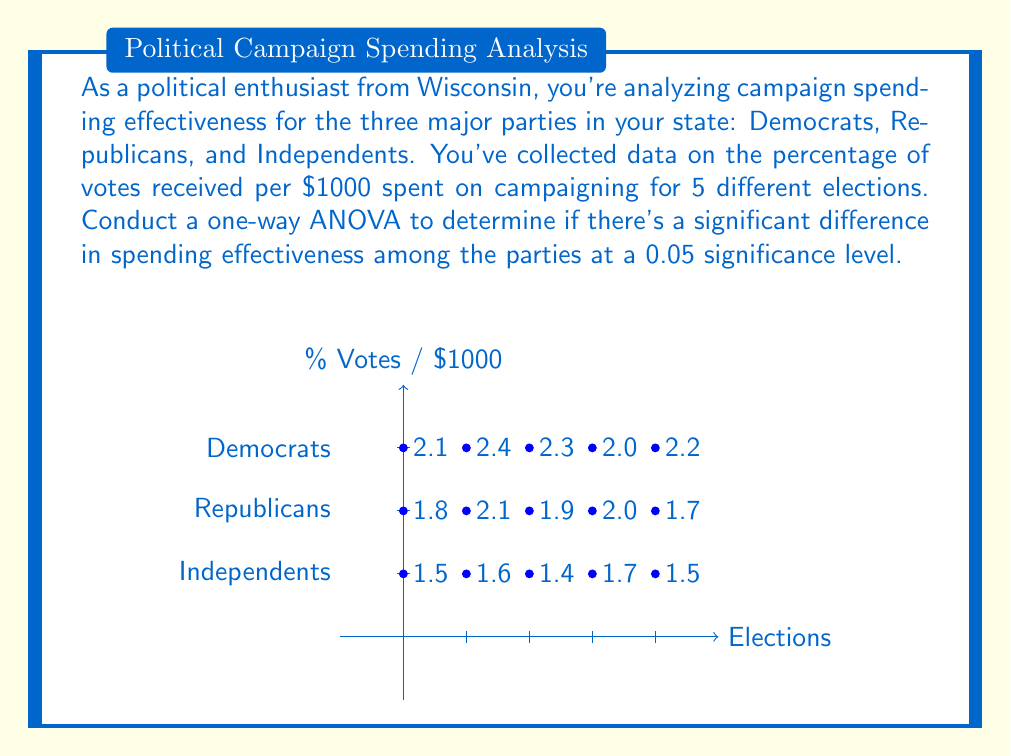Teach me how to tackle this problem. Let's approach this step-by-step:

1) First, we need to calculate the following:
   - Grand mean
   - Sum of squares total (SST)
   - Sum of squares between groups (SSB)
   - Sum of squares within groups (SSW)

2) Calculate the grand mean:
   $\bar{X} = \frac{2.1 + 2.4 + ... + 1.5}{15} = 1.88$

3) Calculate SST:
   SST = $\sum_{i=1}^{3}\sum_{j=1}^{5}(X_{ij} - \bar{X})^2$
       = $(2.1 - 1.88)^2 + (2.4 - 1.88)^2 + ... + (1.5 - 1.88)^2$
       = 1.4347

4) Calculate SSB:
   SSB = $5[(2.2 - 1.88)^2 + (1.9 - 1.88)^2 + (1.54 - 1.88)^2]$
       = 1.1613

5) Calculate SSW:
   SSW = SST - SSB = 1.4347 - 1.1613 = 0.2734

6) Degrees of freedom:
   df(between) = 3 - 1 = 2
   df(within) = 15 - 3 = 12
   df(total) = 15 - 1 = 14

7) Mean Square:
   MS(between) = SSB / df(between) = 1.1613 / 2 = 0.58065
   MS(within) = SSW / df(within) = 0.2734 / 12 = 0.02278

8) F-statistic:
   F = MS(between) / MS(within) = 0.58065 / 0.02278 = 25.49

9) The critical F-value for α = 0.05, df(between) = 2, and df(within) = 12 is approximately 3.89.

10) Since 25.49 > 3.89, we reject the null hypothesis.
Answer: Reject null hypothesis; significant difference in spending effectiveness (F = 25.49, p < 0.05) 